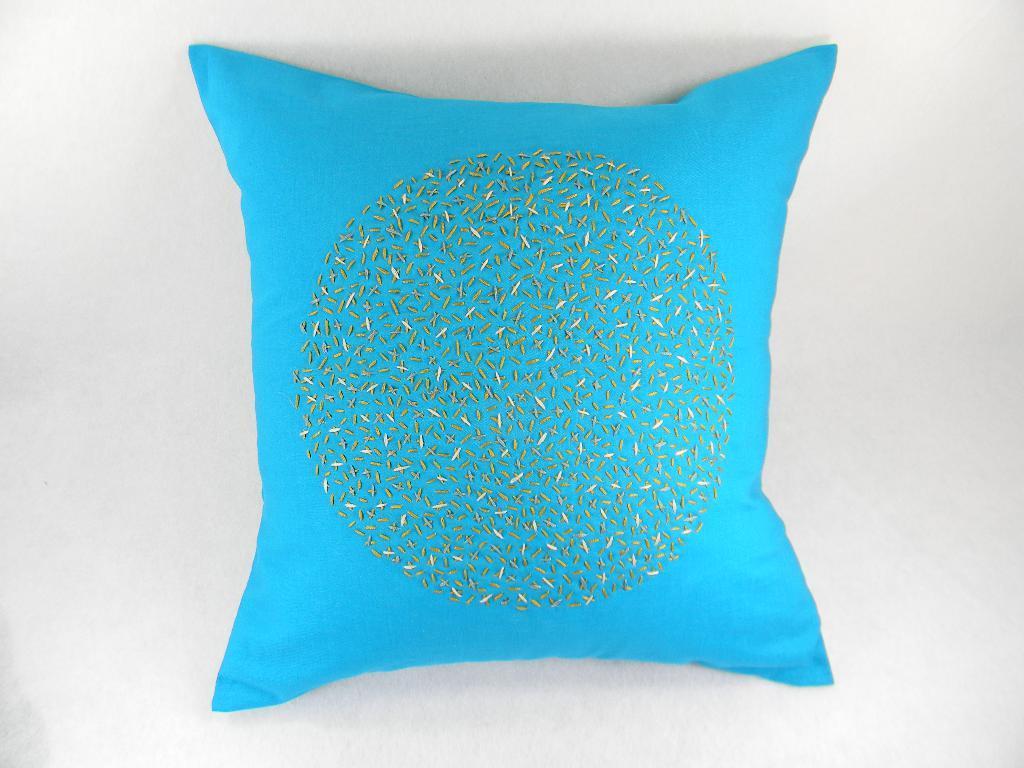How would you summarize this image in a sentence or two? In this image there is a blue color pillow, the background of the image is white in color. 